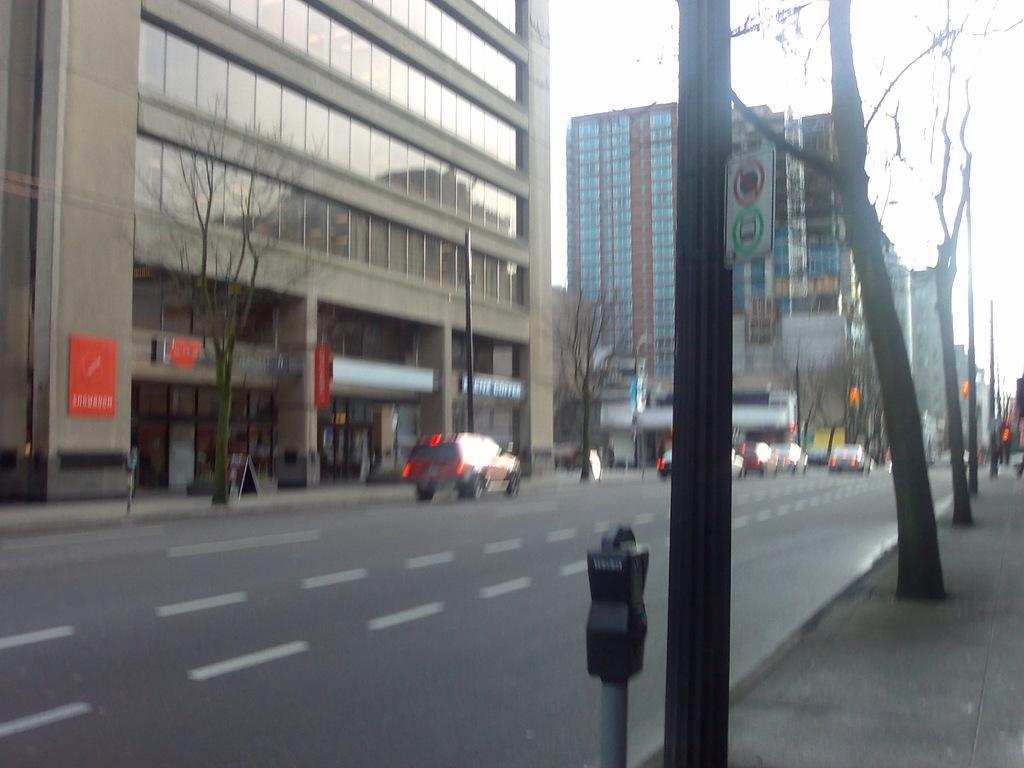How would you summarize this image in a sentence or two? In this image there are vehicles passing on the road, beside the road on the pavement there are pedestrians walking and there are trees, traffic lights, sign boards, lamp posts and buildings. 